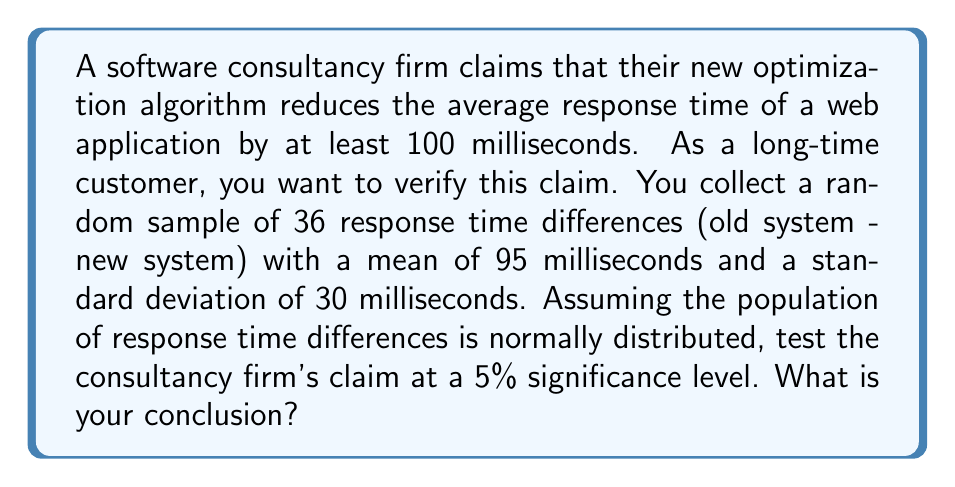Can you answer this question? Let's approach this problem step-by-step using hypothesis testing:

1) Define the hypotheses:
   $H_0: \mu \leq 100$ (null hypothesis)
   $H_a: \mu > 100$ (alternative hypothesis)
   Where $\mu$ is the true mean reduction in response time.

2) Choose the significance level:
   $\alpha = 0.05$ (given in the question)

3) Calculate the test statistic:
   We use a one-sample t-test because we don't know the population standard deviation.
   
   $t = \frac{\bar{x} - \mu_0}{s/\sqrt{n}}$
   
   Where:
   $\bar{x} = 95$ (sample mean)
   $\mu_0 = 100$ (hypothesized population mean)
   $s = 30$ (sample standard deviation)
   $n = 36$ (sample size)

   $t = \frac{95 - 100}{30/\sqrt{36}} = \frac{-5}{5} = -1$

4) Determine the critical value:
   For a one-tailed test with $\alpha = 0.05$ and $df = 35$, the critical t-value is approximately 1.69 (from t-distribution table).

5) Compare the test statistic to the critical value:
   Since $-1 < 1.69$, we fail to reject the null hypothesis.

6) Calculate the p-value:
   Using a t-distribution calculator or table, we find that the p-value for $t = -1$ with $df = 35$ is approximately 0.8371 for a one-tailed test.

   Since $p-value > \alpha$ (0.8371 > 0.05), we fail to reject the null hypothesis.
Answer: Fail to reject $H_0$. Insufficient evidence to support the consultancy firm's claim. 